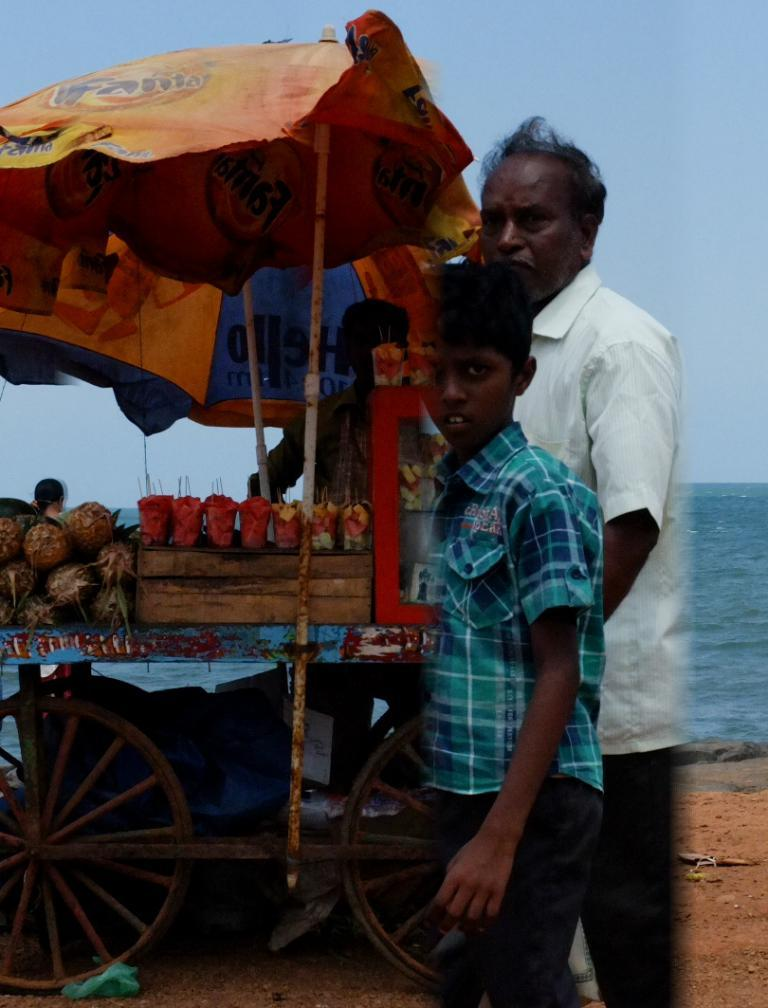How many people are present in the image? There are two persons in the image. What is the cart used for in the image? The cart is likely used for carrying or displaying the fruits in the image. What type of fruits can be seen in the image? The image contains fruits, but the specific types cannot be determined without more information. What are the umbrellas used for in the image? The umbrellas are likely used for providing shade or protection from the sun or rain. What is the ground made of in the image? The ground's composition cannot be determined from the image alone. What other objects are present in the image besides the cart and fruits? There are other objects in the image, but without more information, it is impossible to provide a detailed list of these objects. Can you tell me which country the persons in the image are from? There is no information in the image to determine the nationality or country of origin of the persons in the image. How many times did the persons in the image kiss during the operation? There is no information in the image about an operation or any kissing, so it is not possible to answer this question. 